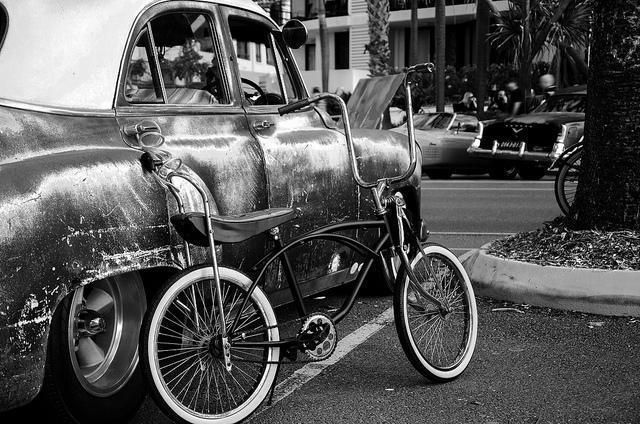How many bicycles are in the photo?
Give a very brief answer. 2. How many bikes are on the car?
Give a very brief answer. 1. How many cars can you see?
Give a very brief answer. 3. 